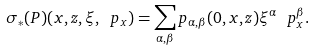Convert formula to latex. <formula><loc_0><loc_0><loc_500><loc_500>\sigma _ { * } ( P ) ( x , z , \xi , \ p _ { x } ) = \sum _ { \alpha , \beta } p _ { \alpha , \beta } ( 0 , x , z ) \xi ^ { \alpha } \ p _ { x } ^ { \beta } .</formula> 